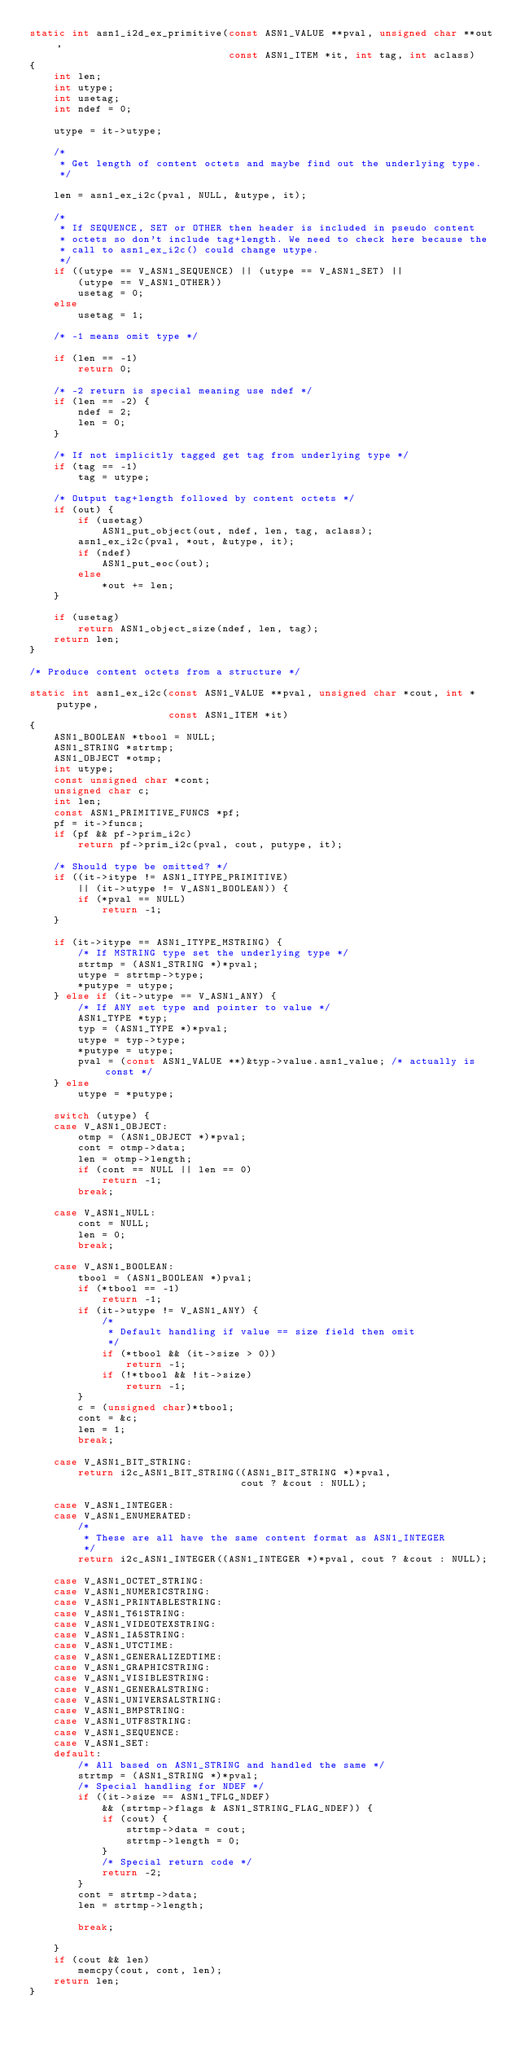<code> <loc_0><loc_0><loc_500><loc_500><_C_>static int asn1_i2d_ex_primitive(const ASN1_VALUE **pval, unsigned char **out,
                                 const ASN1_ITEM *it, int tag, int aclass)
{
    int len;
    int utype;
    int usetag;
    int ndef = 0;

    utype = it->utype;

    /*
     * Get length of content octets and maybe find out the underlying type.
     */

    len = asn1_ex_i2c(pval, NULL, &utype, it);

    /*
     * If SEQUENCE, SET or OTHER then header is included in pseudo content
     * octets so don't include tag+length. We need to check here because the
     * call to asn1_ex_i2c() could change utype.
     */
    if ((utype == V_ASN1_SEQUENCE) || (utype == V_ASN1_SET) ||
        (utype == V_ASN1_OTHER))
        usetag = 0;
    else
        usetag = 1;

    /* -1 means omit type */

    if (len == -1)
        return 0;

    /* -2 return is special meaning use ndef */
    if (len == -2) {
        ndef = 2;
        len = 0;
    }

    /* If not implicitly tagged get tag from underlying type */
    if (tag == -1)
        tag = utype;

    /* Output tag+length followed by content octets */
    if (out) {
        if (usetag)
            ASN1_put_object(out, ndef, len, tag, aclass);
        asn1_ex_i2c(pval, *out, &utype, it);
        if (ndef)
            ASN1_put_eoc(out);
        else
            *out += len;
    }

    if (usetag)
        return ASN1_object_size(ndef, len, tag);
    return len;
}

/* Produce content octets from a structure */

static int asn1_ex_i2c(const ASN1_VALUE **pval, unsigned char *cout, int *putype,
                       const ASN1_ITEM *it)
{
    ASN1_BOOLEAN *tbool = NULL;
    ASN1_STRING *strtmp;
    ASN1_OBJECT *otmp;
    int utype;
    const unsigned char *cont;
    unsigned char c;
    int len;
    const ASN1_PRIMITIVE_FUNCS *pf;
    pf = it->funcs;
    if (pf && pf->prim_i2c)
        return pf->prim_i2c(pval, cout, putype, it);

    /* Should type be omitted? */
    if ((it->itype != ASN1_ITYPE_PRIMITIVE)
        || (it->utype != V_ASN1_BOOLEAN)) {
        if (*pval == NULL)
            return -1;
    }

    if (it->itype == ASN1_ITYPE_MSTRING) {
        /* If MSTRING type set the underlying type */
        strtmp = (ASN1_STRING *)*pval;
        utype = strtmp->type;
        *putype = utype;
    } else if (it->utype == V_ASN1_ANY) {
        /* If ANY set type and pointer to value */
        ASN1_TYPE *typ;
        typ = (ASN1_TYPE *)*pval;
        utype = typ->type;
        *putype = utype;
        pval = (const ASN1_VALUE **)&typ->value.asn1_value; /* actually is const */
    } else
        utype = *putype;

    switch (utype) {
    case V_ASN1_OBJECT:
        otmp = (ASN1_OBJECT *)*pval;
        cont = otmp->data;
        len = otmp->length;
        if (cont == NULL || len == 0)
            return -1;
        break;

    case V_ASN1_NULL:
        cont = NULL;
        len = 0;
        break;

    case V_ASN1_BOOLEAN:
        tbool = (ASN1_BOOLEAN *)pval;
        if (*tbool == -1)
            return -1;
        if (it->utype != V_ASN1_ANY) {
            /*
             * Default handling if value == size field then omit
             */
            if (*tbool && (it->size > 0))
                return -1;
            if (!*tbool && !it->size)
                return -1;
        }
        c = (unsigned char)*tbool;
        cont = &c;
        len = 1;
        break;

    case V_ASN1_BIT_STRING:
        return i2c_ASN1_BIT_STRING((ASN1_BIT_STRING *)*pval,
                                   cout ? &cout : NULL);

    case V_ASN1_INTEGER:
    case V_ASN1_ENUMERATED:
        /*
         * These are all have the same content format as ASN1_INTEGER
         */
        return i2c_ASN1_INTEGER((ASN1_INTEGER *)*pval, cout ? &cout : NULL);

    case V_ASN1_OCTET_STRING:
    case V_ASN1_NUMERICSTRING:
    case V_ASN1_PRINTABLESTRING:
    case V_ASN1_T61STRING:
    case V_ASN1_VIDEOTEXSTRING:
    case V_ASN1_IA5STRING:
    case V_ASN1_UTCTIME:
    case V_ASN1_GENERALIZEDTIME:
    case V_ASN1_GRAPHICSTRING:
    case V_ASN1_VISIBLESTRING:
    case V_ASN1_GENERALSTRING:
    case V_ASN1_UNIVERSALSTRING:
    case V_ASN1_BMPSTRING:
    case V_ASN1_UTF8STRING:
    case V_ASN1_SEQUENCE:
    case V_ASN1_SET:
    default:
        /* All based on ASN1_STRING and handled the same */
        strtmp = (ASN1_STRING *)*pval;
        /* Special handling for NDEF */
        if ((it->size == ASN1_TFLG_NDEF)
            && (strtmp->flags & ASN1_STRING_FLAG_NDEF)) {
            if (cout) {
                strtmp->data = cout;
                strtmp->length = 0;
            }
            /* Special return code */
            return -2;
        }
        cont = strtmp->data;
        len = strtmp->length;

        break;

    }
    if (cout && len)
        memcpy(cout, cont, len);
    return len;
}
</code> 